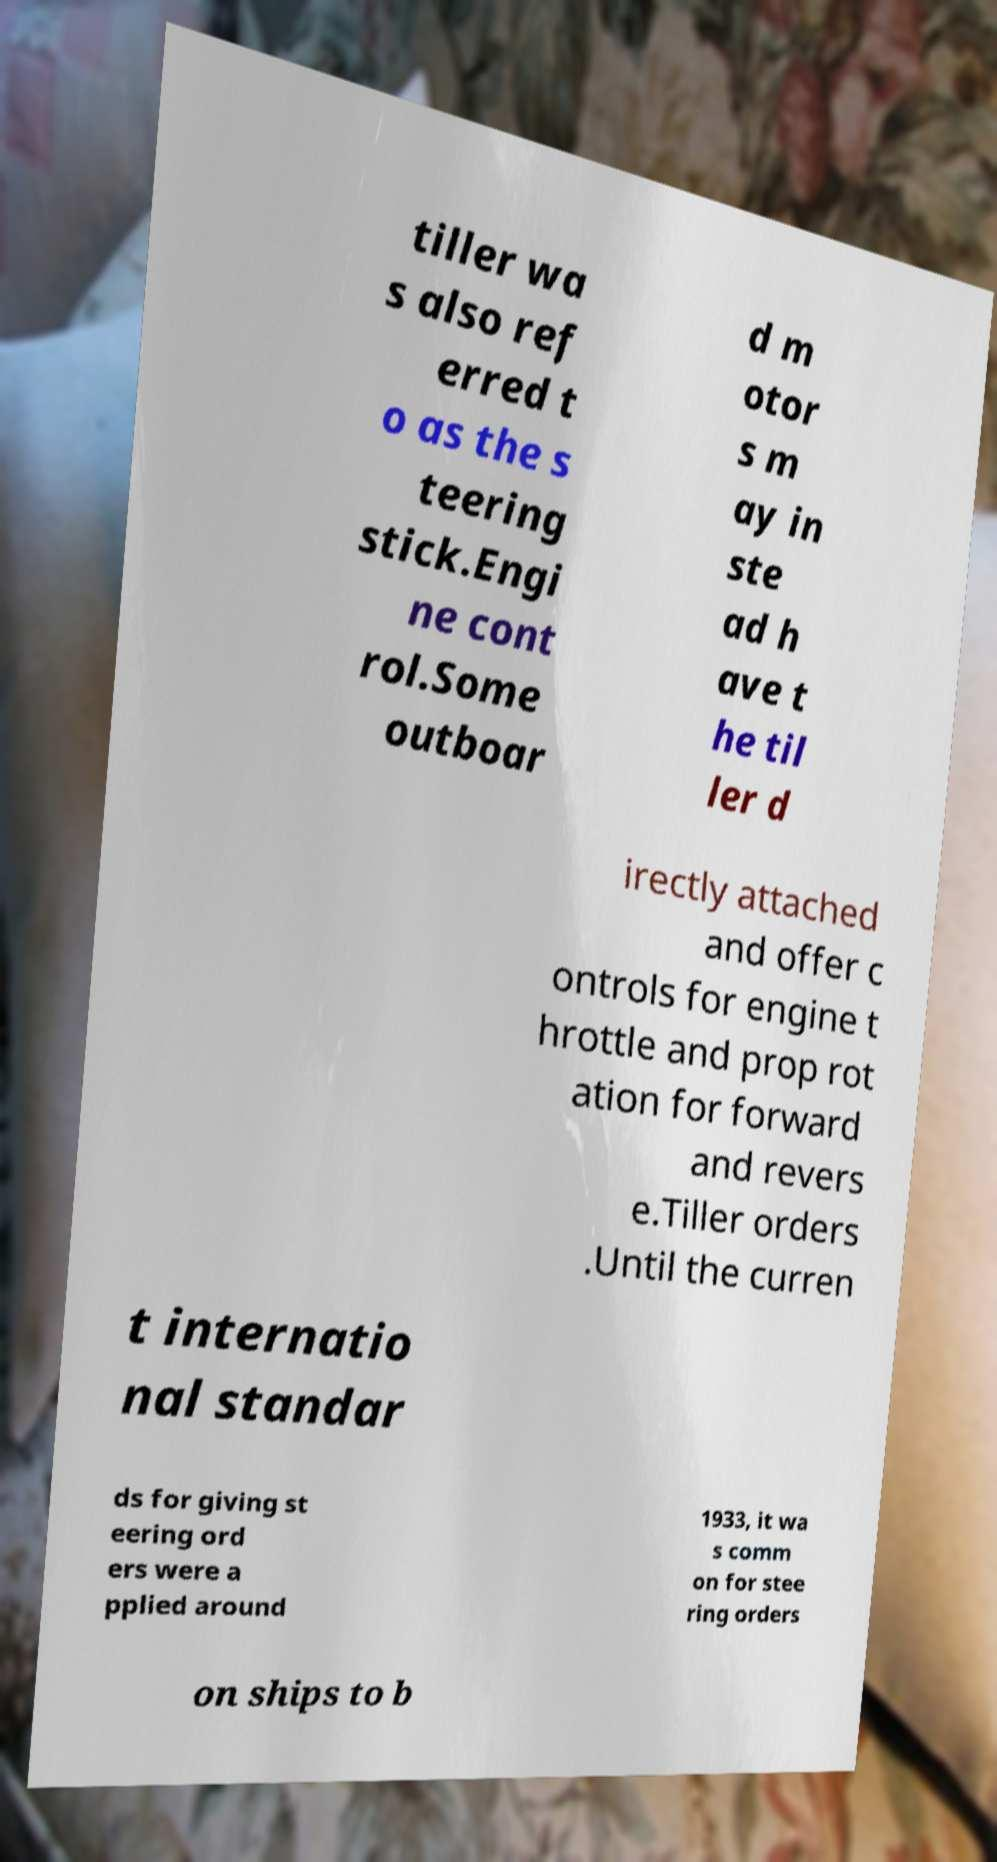Please identify and transcribe the text found in this image. tiller wa s also ref erred t o as the s teering stick.Engi ne cont rol.Some outboar d m otor s m ay in ste ad h ave t he til ler d irectly attached and offer c ontrols for engine t hrottle and prop rot ation for forward and revers e.Tiller orders .Until the curren t internatio nal standar ds for giving st eering ord ers were a pplied around 1933, it wa s comm on for stee ring orders on ships to b 